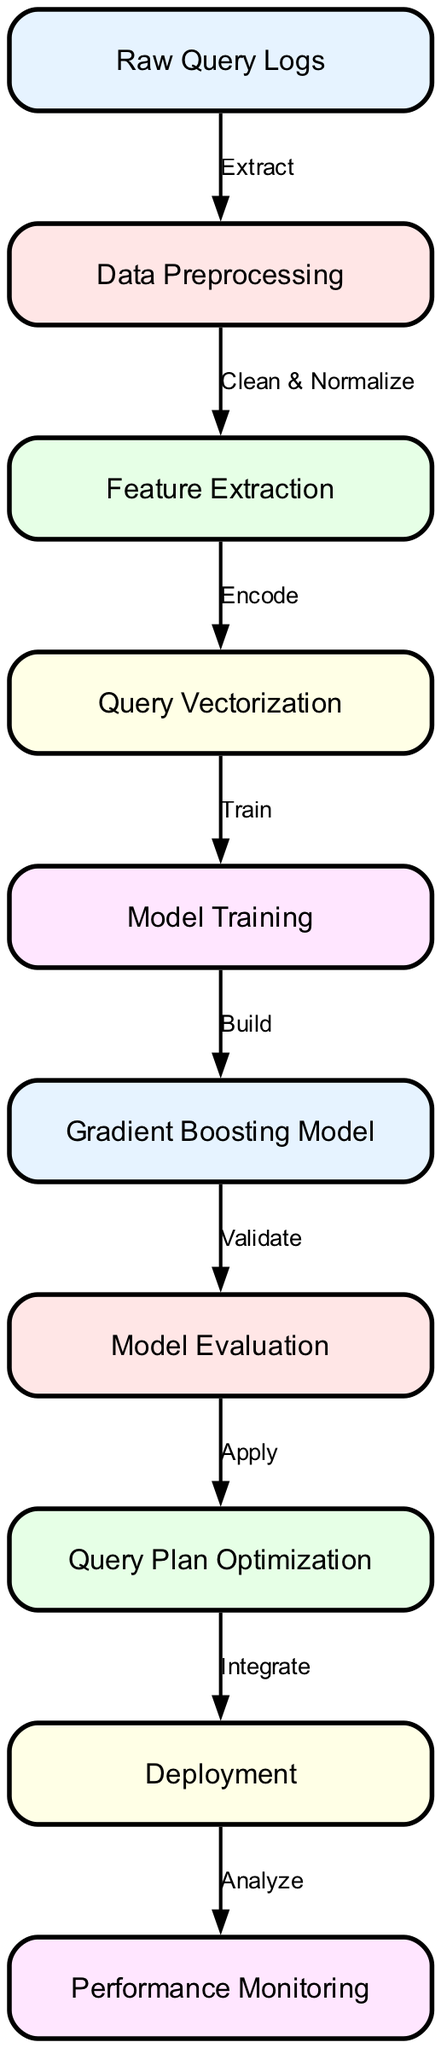What is the first stage in the machine learning pipeline? The diagram indicates that the first stage (node) is "Raw Query Logs," which serves as the initial input for the entire process.
Answer: Raw Query Logs How many nodes are there in total in the diagram? By counting the nodes listed, there are ten distinct nodes outlined in the machine learning pipeline diagram.
Answer: 10 Which node follows "Data Preprocessing"? The flow of the diagram shows that "Feature Extraction" is the node that directly follows "Data Preprocessing," connecting these two stages.
Answer: Feature Extraction What is the label of the node connected to "Model Training"? The node labeled "Gradient Boosting Model" is connected to "Model Training," indicating the output of the training stage.
Answer: Gradient Boosting Model What process is applied after "Model Evaluation"? According to the diagram, "Query Plan Optimization" is the process that takes place immediately after "Model Evaluation."
Answer: Query Plan Optimization What action is represented by the edge between "Query Vectorization" and "Model Training"? The diagram indicates that the label of the edge connecting these two nodes is "Train," which denotes the action taken between them.
Answer: Train Which node is responsible for the last action of the pipeline? The diagram shows that "Performance Monitoring" is the last action performed in the pipeline, indicating ongoing monitoring after deployment.
Answer: Performance Monitoring What relationship exists between "Deployment" and "Performance Monitoring"? The diagram illustrates that "Deployment" feeds into "Performance Monitoring," meaning that post-deployment, the performance of the system is actively monitored.
Answer: Deploys to Performance Monitoring What is the output of the "Gradient Boosting Model"? The model trained indicated by "Model Training," which outputs the "Gradient Boosting Model," suggests this is an artifact of the training process.
Answer: Gradient Boosting Model What stage comes before "Query Plan Optimization"? Reviewing the flow, "Model Evaluation" is the preceding stage to "Query Plan Optimization," indicating that evaluation precedes optimization in the pipeline.
Answer: Model Evaluation 